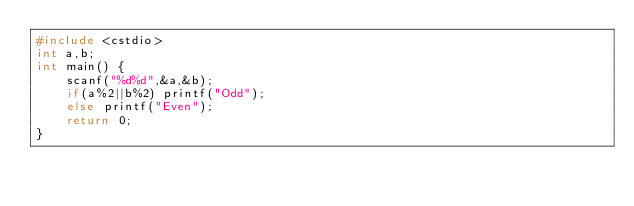Convert code to text. <code><loc_0><loc_0><loc_500><loc_500><_C++_>#include <cstdio>
int a,b;
int main() {
	scanf("%d%d",&a,&b);
	if(a%2||b%2) printf("Odd");
	else printf("Even");
	return 0;
}</code> 